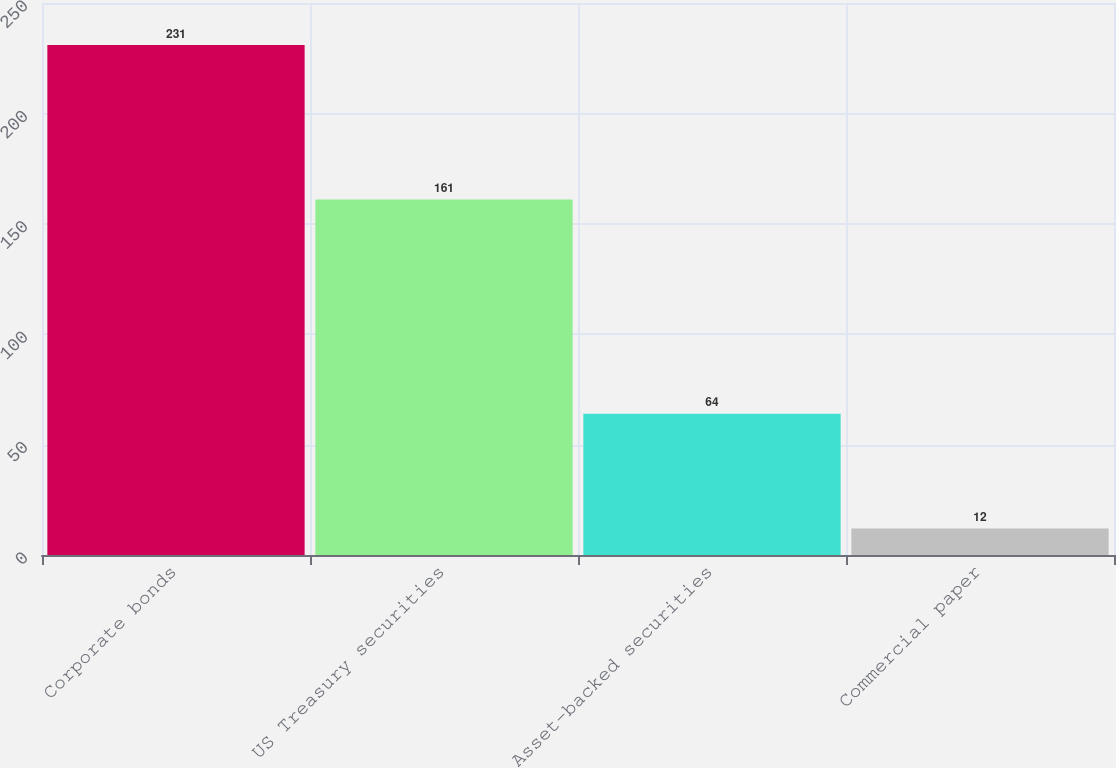Convert chart to OTSL. <chart><loc_0><loc_0><loc_500><loc_500><bar_chart><fcel>Corporate bonds<fcel>US Treasury securities<fcel>Asset-backed securities<fcel>Commercial paper<nl><fcel>231<fcel>161<fcel>64<fcel>12<nl></chart> 